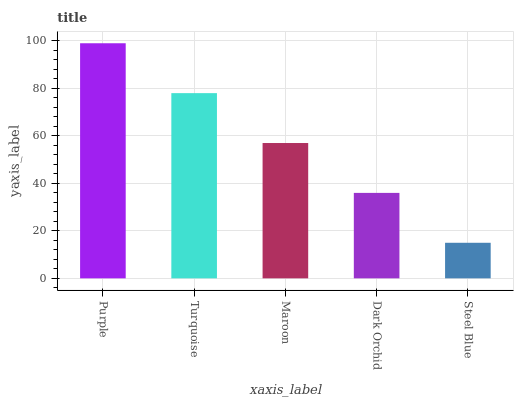Is Steel Blue the minimum?
Answer yes or no. Yes. Is Purple the maximum?
Answer yes or no. Yes. Is Turquoise the minimum?
Answer yes or no. No. Is Turquoise the maximum?
Answer yes or no. No. Is Purple greater than Turquoise?
Answer yes or no. Yes. Is Turquoise less than Purple?
Answer yes or no. Yes. Is Turquoise greater than Purple?
Answer yes or no. No. Is Purple less than Turquoise?
Answer yes or no. No. Is Maroon the high median?
Answer yes or no. Yes. Is Maroon the low median?
Answer yes or no. Yes. Is Purple the high median?
Answer yes or no. No. Is Purple the low median?
Answer yes or no. No. 